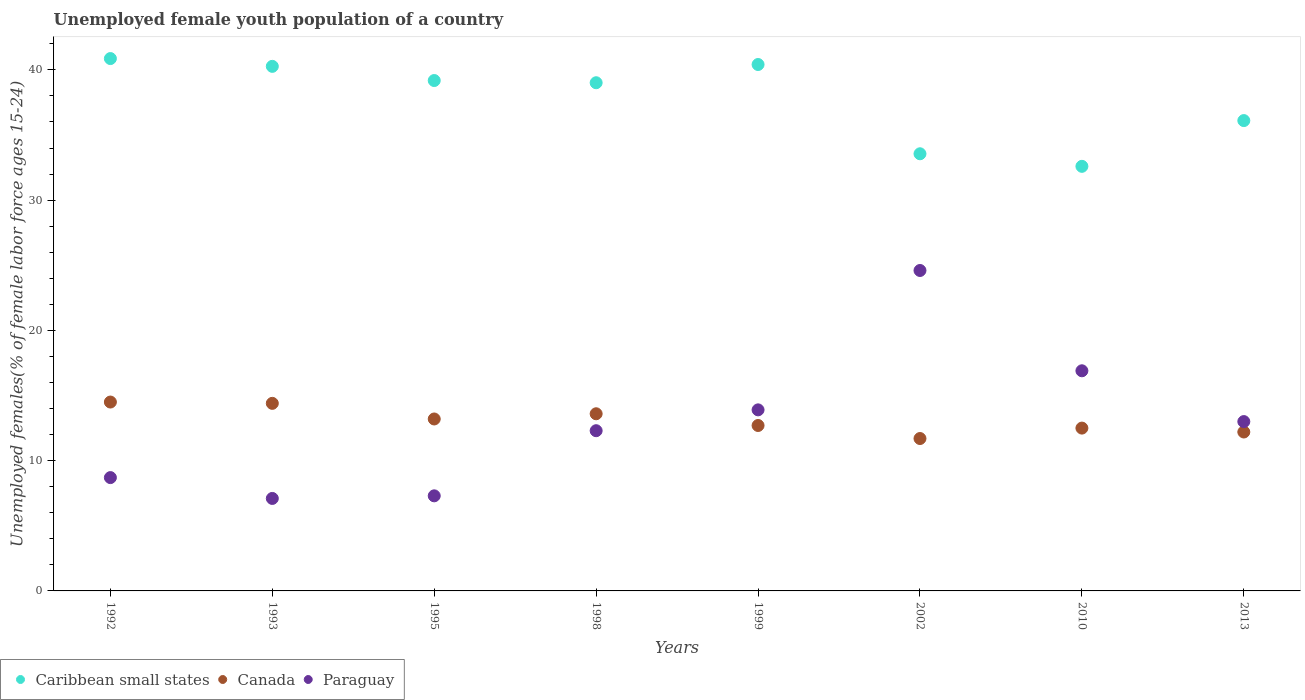How many different coloured dotlines are there?
Your answer should be compact. 3. Is the number of dotlines equal to the number of legend labels?
Make the answer very short. Yes. What is the percentage of unemployed female youth population in Caribbean small states in 2010?
Offer a very short reply. 32.6. Across all years, what is the maximum percentage of unemployed female youth population in Canada?
Provide a succinct answer. 14.5. Across all years, what is the minimum percentage of unemployed female youth population in Paraguay?
Keep it short and to the point. 7.1. In which year was the percentage of unemployed female youth population in Canada maximum?
Offer a terse response. 1992. In which year was the percentage of unemployed female youth population in Paraguay minimum?
Provide a short and direct response. 1993. What is the total percentage of unemployed female youth population in Caribbean small states in the graph?
Give a very brief answer. 302.01. What is the difference between the percentage of unemployed female youth population in Paraguay in 2010 and that in 2013?
Your response must be concise. 3.9. What is the difference between the percentage of unemployed female youth population in Canada in 1993 and the percentage of unemployed female youth population in Paraguay in 1999?
Your response must be concise. 0.5. What is the average percentage of unemployed female youth population in Caribbean small states per year?
Give a very brief answer. 37.75. In the year 1995, what is the difference between the percentage of unemployed female youth population in Canada and percentage of unemployed female youth population in Caribbean small states?
Your answer should be compact. -25.98. In how many years, is the percentage of unemployed female youth population in Caribbean small states greater than 40 %?
Provide a succinct answer. 3. What is the ratio of the percentage of unemployed female youth population in Caribbean small states in 1999 to that in 2013?
Keep it short and to the point. 1.12. Is the difference between the percentage of unemployed female youth population in Canada in 1992 and 2002 greater than the difference between the percentage of unemployed female youth population in Caribbean small states in 1992 and 2002?
Offer a very short reply. No. What is the difference between the highest and the second highest percentage of unemployed female youth population in Canada?
Provide a succinct answer. 0.1. What is the difference between the highest and the lowest percentage of unemployed female youth population in Canada?
Give a very brief answer. 2.8. In how many years, is the percentage of unemployed female youth population in Paraguay greater than the average percentage of unemployed female youth population in Paraguay taken over all years?
Your answer should be very brief. 4. Is the sum of the percentage of unemployed female youth population in Canada in 1995 and 1998 greater than the maximum percentage of unemployed female youth population in Paraguay across all years?
Keep it short and to the point. Yes. Is it the case that in every year, the sum of the percentage of unemployed female youth population in Caribbean small states and percentage of unemployed female youth population in Canada  is greater than the percentage of unemployed female youth population in Paraguay?
Your answer should be very brief. Yes. Is the percentage of unemployed female youth population in Canada strictly greater than the percentage of unemployed female youth population in Caribbean small states over the years?
Your answer should be compact. No. Is the percentage of unemployed female youth population in Caribbean small states strictly less than the percentage of unemployed female youth population in Paraguay over the years?
Ensure brevity in your answer.  No. How many dotlines are there?
Offer a very short reply. 3. How many years are there in the graph?
Keep it short and to the point. 8. Are the values on the major ticks of Y-axis written in scientific E-notation?
Ensure brevity in your answer.  No. Does the graph contain any zero values?
Offer a terse response. No. What is the title of the graph?
Give a very brief answer. Unemployed female youth population of a country. What is the label or title of the Y-axis?
Your response must be concise. Unemployed females(% of female labor force ages 15-24). What is the Unemployed females(% of female labor force ages 15-24) in Caribbean small states in 1992?
Keep it short and to the point. 40.87. What is the Unemployed females(% of female labor force ages 15-24) in Paraguay in 1992?
Make the answer very short. 8.7. What is the Unemployed females(% of female labor force ages 15-24) in Caribbean small states in 1993?
Ensure brevity in your answer.  40.27. What is the Unemployed females(% of female labor force ages 15-24) in Canada in 1993?
Ensure brevity in your answer.  14.4. What is the Unemployed females(% of female labor force ages 15-24) in Paraguay in 1993?
Keep it short and to the point. 7.1. What is the Unemployed females(% of female labor force ages 15-24) of Caribbean small states in 1995?
Your response must be concise. 39.18. What is the Unemployed females(% of female labor force ages 15-24) in Canada in 1995?
Your answer should be very brief. 13.2. What is the Unemployed females(% of female labor force ages 15-24) of Paraguay in 1995?
Give a very brief answer. 7.3. What is the Unemployed females(% of female labor force ages 15-24) in Caribbean small states in 1998?
Offer a terse response. 39.01. What is the Unemployed females(% of female labor force ages 15-24) in Canada in 1998?
Your answer should be compact. 13.6. What is the Unemployed females(% of female labor force ages 15-24) of Paraguay in 1998?
Your answer should be very brief. 12.3. What is the Unemployed females(% of female labor force ages 15-24) of Caribbean small states in 1999?
Offer a terse response. 40.41. What is the Unemployed females(% of female labor force ages 15-24) in Canada in 1999?
Ensure brevity in your answer.  12.7. What is the Unemployed females(% of female labor force ages 15-24) in Paraguay in 1999?
Offer a very short reply. 13.9. What is the Unemployed females(% of female labor force ages 15-24) of Caribbean small states in 2002?
Your answer should be compact. 33.56. What is the Unemployed females(% of female labor force ages 15-24) of Canada in 2002?
Your answer should be very brief. 11.7. What is the Unemployed females(% of female labor force ages 15-24) of Paraguay in 2002?
Your answer should be very brief. 24.6. What is the Unemployed females(% of female labor force ages 15-24) in Caribbean small states in 2010?
Offer a terse response. 32.6. What is the Unemployed females(% of female labor force ages 15-24) in Canada in 2010?
Make the answer very short. 12.5. What is the Unemployed females(% of female labor force ages 15-24) of Paraguay in 2010?
Provide a short and direct response. 16.9. What is the Unemployed females(% of female labor force ages 15-24) in Caribbean small states in 2013?
Provide a short and direct response. 36.11. What is the Unemployed females(% of female labor force ages 15-24) of Canada in 2013?
Keep it short and to the point. 12.2. Across all years, what is the maximum Unemployed females(% of female labor force ages 15-24) in Caribbean small states?
Your response must be concise. 40.87. Across all years, what is the maximum Unemployed females(% of female labor force ages 15-24) of Paraguay?
Provide a succinct answer. 24.6. Across all years, what is the minimum Unemployed females(% of female labor force ages 15-24) in Caribbean small states?
Provide a succinct answer. 32.6. Across all years, what is the minimum Unemployed females(% of female labor force ages 15-24) of Canada?
Give a very brief answer. 11.7. Across all years, what is the minimum Unemployed females(% of female labor force ages 15-24) of Paraguay?
Offer a terse response. 7.1. What is the total Unemployed females(% of female labor force ages 15-24) of Caribbean small states in the graph?
Provide a short and direct response. 302.01. What is the total Unemployed females(% of female labor force ages 15-24) in Canada in the graph?
Your answer should be very brief. 104.8. What is the total Unemployed females(% of female labor force ages 15-24) in Paraguay in the graph?
Provide a short and direct response. 103.8. What is the difference between the Unemployed females(% of female labor force ages 15-24) in Caribbean small states in 1992 and that in 1993?
Give a very brief answer. 0.6. What is the difference between the Unemployed females(% of female labor force ages 15-24) in Caribbean small states in 1992 and that in 1995?
Offer a terse response. 1.69. What is the difference between the Unemployed females(% of female labor force ages 15-24) in Paraguay in 1992 and that in 1995?
Provide a succinct answer. 1.4. What is the difference between the Unemployed females(% of female labor force ages 15-24) of Caribbean small states in 1992 and that in 1998?
Your answer should be compact. 1.86. What is the difference between the Unemployed females(% of female labor force ages 15-24) in Canada in 1992 and that in 1998?
Make the answer very short. 0.9. What is the difference between the Unemployed females(% of female labor force ages 15-24) of Paraguay in 1992 and that in 1998?
Ensure brevity in your answer.  -3.6. What is the difference between the Unemployed females(% of female labor force ages 15-24) in Caribbean small states in 1992 and that in 1999?
Keep it short and to the point. 0.46. What is the difference between the Unemployed females(% of female labor force ages 15-24) of Canada in 1992 and that in 1999?
Your response must be concise. 1.8. What is the difference between the Unemployed females(% of female labor force ages 15-24) of Caribbean small states in 1992 and that in 2002?
Ensure brevity in your answer.  7.31. What is the difference between the Unemployed females(% of female labor force ages 15-24) of Paraguay in 1992 and that in 2002?
Keep it short and to the point. -15.9. What is the difference between the Unemployed females(% of female labor force ages 15-24) in Caribbean small states in 1992 and that in 2010?
Your answer should be very brief. 8.27. What is the difference between the Unemployed females(% of female labor force ages 15-24) in Caribbean small states in 1992 and that in 2013?
Offer a terse response. 4.76. What is the difference between the Unemployed females(% of female labor force ages 15-24) in Canada in 1992 and that in 2013?
Offer a very short reply. 2.3. What is the difference between the Unemployed females(% of female labor force ages 15-24) in Caribbean small states in 1993 and that in 1995?
Offer a terse response. 1.09. What is the difference between the Unemployed females(% of female labor force ages 15-24) in Canada in 1993 and that in 1995?
Provide a succinct answer. 1.2. What is the difference between the Unemployed females(% of female labor force ages 15-24) in Paraguay in 1993 and that in 1995?
Offer a terse response. -0.2. What is the difference between the Unemployed females(% of female labor force ages 15-24) of Caribbean small states in 1993 and that in 1998?
Offer a very short reply. 1.26. What is the difference between the Unemployed females(% of female labor force ages 15-24) of Canada in 1993 and that in 1998?
Make the answer very short. 0.8. What is the difference between the Unemployed females(% of female labor force ages 15-24) in Caribbean small states in 1993 and that in 1999?
Keep it short and to the point. -0.14. What is the difference between the Unemployed females(% of female labor force ages 15-24) in Canada in 1993 and that in 1999?
Ensure brevity in your answer.  1.7. What is the difference between the Unemployed females(% of female labor force ages 15-24) in Paraguay in 1993 and that in 1999?
Ensure brevity in your answer.  -6.8. What is the difference between the Unemployed females(% of female labor force ages 15-24) of Caribbean small states in 1993 and that in 2002?
Your answer should be compact. 6.71. What is the difference between the Unemployed females(% of female labor force ages 15-24) in Canada in 1993 and that in 2002?
Provide a short and direct response. 2.7. What is the difference between the Unemployed females(% of female labor force ages 15-24) in Paraguay in 1993 and that in 2002?
Offer a terse response. -17.5. What is the difference between the Unemployed females(% of female labor force ages 15-24) in Caribbean small states in 1993 and that in 2010?
Provide a short and direct response. 7.68. What is the difference between the Unemployed females(% of female labor force ages 15-24) in Paraguay in 1993 and that in 2010?
Ensure brevity in your answer.  -9.8. What is the difference between the Unemployed females(% of female labor force ages 15-24) in Caribbean small states in 1993 and that in 2013?
Offer a very short reply. 4.16. What is the difference between the Unemployed females(% of female labor force ages 15-24) in Canada in 1993 and that in 2013?
Offer a very short reply. 2.2. What is the difference between the Unemployed females(% of female labor force ages 15-24) in Paraguay in 1993 and that in 2013?
Keep it short and to the point. -5.9. What is the difference between the Unemployed females(% of female labor force ages 15-24) in Caribbean small states in 1995 and that in 1998?
Keep it short and to the point. 0.17. What is the difference between the Unemployed females(% of female labor force ages 15-24) of Paraguay in 1995 and that in 1998?
Offer a terse response. -5. What is the difference between the Unemployed females(% of female labor force ages 15-24) of Caribbean small states in 1995 and that in 1999?
Give a very brief answer. -1.23. What is the difference between the Unemployed females(% of female labor force ages 15-24) in Paraguay in 1995 and that in 1999?
Your answer should be compact. -6.6. What is the difference between the Unemployed females(% of female labor force ages 15-24) of Caribbean small states in 1995 and that in 2002?
Give a very brief answer. 5.62. What is the difference between the Unemployed females(% of female labor force ages 15-24) in Canada in 1995 and that in 2002?
Offer a terse response. 1.5. What is the difference between the Unemployed females(% of female labor force ages 15-24) of Paraguay in 1995 and that in 2002?
Offer a very short reply. -17.3. What is the difference between the Unemployed females(% of female labor force ages 15-24) in Caribbean small states in 1995 and that in 2010?
Provide a short and direct response. 6.59. What is the difference between the Unemployed females(% of female labor force ages 15-24) of Paraguay in 1995 and that in 2010?
Offer a terse response. -9.6. What is the difference between the Unemployed females(% of female labor force ages 15-24) of Caribbean small states in 1995 and that in 2013?
Make the answer very short. 3.08. What is the difference between the Unemployed females(% of female labor force ages 15-24) of Paraguay in 1995 and that in 2013?
Ensure brevity in your answer.  -5.7. What is the difference between the Unemployed females(% of female labor force ages 15-24) in Caribbean small states in 1998 and that in 1999?
Provide a succinct answer. -1.4. What is the difference between the Unemployed females(% of female labor force ages 15-24) of Canada in 1998 and that in 1999?
Provide a succinct answer. 0.9. What is the difference between the Unemployed females(% of female labor force ages 15-24) of Paraguay in 1998 and that in 1999?
Make the answer very short. -1.6. What is the difference between the Unemployed females(% of female labor force ages 15-24) in Caribbean small states in 1998 and that in 2002?
Keep it short and to the point. 5.45. What is the difference between the Unemployed females(% of female labor force ages 15-24) of Canada in 1998 and that in 2002?
Your answer should be compact. 1.9. What is the difference between the Unemployed females(% of female labor force ages 15-24) of Caribbean small states in 1998 and that in 2010?
Keep it short and to the point. 6.42. What is the difference between the Unemployed females(% of female labor force ages 15-24) in Caribbean small states in 1998 and that in 2013?
Provide a succinct answer. 2.91. What is the difference between the Unemployed females(% of female labor force ages 15-24) in Paraguay in 1998 and that in 2013?
Give a very brief answer. -0.7. What is the difference between the Unemployed females(% of female labor force ages 15-24) in Caribbean small states in 1999 and that in 2002?
Provide a short and direct response. 6.85. What is the difference between the Unemployed females(% of female labor force ages 15-24) in Canada in 1999 and that in 2002?
Offer a very short reply. 1. What is the difference between the Unemployed females(% of female labor force ages 15-24) of Caribbean small states in 1999 and that in 2010?
Give a very brief answer. 7.82. What is the difference between the Unemployed females(% of female labor force ages 15-24) in Caribbean small states in 1999 and that in 2013?
Your response must be concise. 4.31. What is the difference between the Unemployed females(% of female labor force ages 15-24) in Canada in 1999 and that in 2013?
Keep it short and to the point. 0.5. What is the difference between the Unemployed females(% of female labor force ages 15-24) in Paraguay in 1999 and that in 2013?
Your answer should be very brief. 0.9. What is the difference between the Unemployed females(% of female labor force ages 15-24) in Caribbean small states in 2002 and that in 2010?
Your answer should be very brief. 0.96. What is the difference between the Unemployed females(% of female labor force ages 15-24) in Paraguay in 2002 and that in 2010?
Make the answer very short. 7.7. What is the difference between the Unemployed females(% of female labor force ages 15-24) of Caribbean small states in 2002 and that in 2013?
Your answer should be compact. -2.55. What is the difference between the Unemployed females(% of female labor force ages 15-24) in Paraguay in 2002 and that in 2013?
Give a very brief answer. 11.6. What is the difference between the Unemployed females(% of female labor force ages 15-24) in Caribbean small states in 2010 and that in 2013?
Ensure brevity in your answer.  -3.51. What is the difference between the Unemployed females(% of female labor force ages 15-24) in Paraguay in 2010 and that in 2013?
Offer a very short reply. 3.9. What is the difference between the Unemployed females(% of female labor force ages 15-24) of Caribbean small states in 1992 and the Unemployed females(% of female labor force ages 15-24) of Canada in 1993?
Provide a succinct answer. 26.47. What is the difference between the Unemployed females(% of female labor force ages 15-24) in Caribbean small states in 1992 and the Unemployed females(% of female labor force ages 15-24) in Paraguay in 1993?
Your response must be concise. 33.77. What is the difference between the Unemployed females(% of female labor force ages 15-24) of Canada in 1992 and the Unemployed females(% of female labor force ages 15-24) of Paraguay in 1993?
Ensure brevity in your answer.  7.4. What is the difference between the Unemployed females(% of female labor force ages 15-24) in Caribbean small states in 1992 and the Unemployed females(% of female labor force ages 15-24) in Canada in 1995?
Your answer should be compact. 27.67. What is the difference between the Unemployed females(% of female labor force ages 15-24) of Caribbean small states in 1992 and the Unemployed females(% of female labor force ages 15-24) of Paraguay in 1995?
Your answer should be very brief. 33.57. What is the difference between the Unemployed females(% of female labor force ages 15-24) of Canada in 1992 and the Unemployed females(% of female labor force ages 15-24) of Paraguay in 1995?
Make the answer very short. 7.2. What is the difference between the Unemployed females(% of female labor force ages 15-24) of Caribbean small states in 1992 and the Unemployed females(% of female labor force ages 15-24) of Canada in 1998?
Your answer should be compact. 27.27. What is the difference between the Unemployed females(% of female labor force ages 15-24) of Caribbean small states in 1992 and the Unemployed females(% of female labor force ages 15-24) of Paraguay in 1998?
Keep it short and to the point. 28.57. What is the difference between the Unemployed females(% of female labor force ages 15-24) in Caribbean small states in 1992 and the Unemployed females(% of female labor force ages 15-24) in Canada in 1999?
Make the answer very short. 28.17. What is the difference between the Unemployed females(% of female labor force ages 15-24) of Caribbean small states in 1992 and the Unemployed females(% of female labor force ages 15-24) of Paraguay in 1999?
Give a very brief answer. 26.97. What is the difference between the Unemployed females(% of female labor force ages 15-24) of Canada in 1992 and the Unemployed females(% of female labor force ages 15-24) of Paraguay in 1999?
Your answer should be compact. 0.6. What is the difference between the Unemployed females(% of female labor force ages 15-24) of Caribbean small states in 1992 and the Unemployed females(% of female labor force ages 15-24) of Canada in 2002?
Offer a very short reply. 29.17. What is the difference between the Unemployed females(% of female labor force ages 15-24) of Caribbean small states in 1992 and the Unemployed females(% of female labor force ages 15-24) of Paraguay in 2002?
Make the answer very short. 16.27. What is the difference between the Unemployed females(% of female labor force ages 15-24) of Canada in 1992 and the Unemployed females(% of female labor force ages 15-24) of Paraguay in 2002?
Keep it short and to the point. -10.1. What is the difference between the Unemployed females(% of female labor force ages 15-24) of Caribbean small states in 1992 and the Unemployed females(% of female labor force ages 15-24) of Canada in 2010?
Your response must be concise. 28.37. What is the difference between the Unemployed females(% of female labor force ages 15-24) in Caribbean small states in 1992 and the Unemployed females(% of female labor force ages 15-24) in Paraguay in 2010?
Keep it short and to the point. 23.97. What is the difference between the Unemployed females(% of female labor force ages 15-24) of Canada in 1992 and the Unemployed females(% of female labor force ages 15-24) of Paraguay in 2010?
Your answer should be compact. -2.4. What is the difference between the Unemployed females(% of female labor force ages 15-24) of Caribbean small states in 1992 and the Unemployed females(% of female labor force ages 15-24) of Canada in 2013?
Provide a succinct answer. 28.67. What is the difference between the Unemployed females(% of female labor force ages 15-24) of Caribbean small states in 1992 and the Unemployed females(% of female labor force ages 15-24) of Paraguay in 2013?
Your response must be concise. 27.87. What is the difference between the Unemployed females(% of female labor force ages 15-24) of Canada in 1992 and the Unemployed females(% of female labor force ages 15-24) of Paraguay in 2013?
Offer a terse response. 1.5. What is the difference between the Unemployed females(% of female labor force ages 15-24) of Caribbean small states in 1993 and the Unemployed females(% of female labor force ages 15-24) of Canada in 1995?
Keep it short and to the point. 27.07. What is the difference between the Unemployed females(% of female labor force ages 15-24) in Caribbean small states in 1993 and the Unemployed females(% of female labor force ages 15-24) in Paraguay in 1995?
Provide a short and direct response. 32.97. What is the difference between the Unemployed females(% of female labor force ages 15-24) in Canada in 1993 and the Unemployed females(% of female labor force ages 15-24) in Paraguay in 1995?
Keep it short and to the point. 7.1. What is the difference between the Unemployed females(% of female labor force ages 15-24) of Caribbean small states in 1993 and the Unemployed females(% of female labor force ages 15-24) of Canada in 1998?
Your answer should be compact. 26.67. What is the difference between the Unemployed females(% of female labor force ages 15-24) in Caribbean small states in 1993 and the Unemployed females(% of female labor force ages 15-24) in Paraguay in 1998?
Offer a very short reply. 27.97. What is the difference between the Unemployed females(% of female labor force ages 15-24) of Canada in 1993 and the Unemployed females(% of female labor force ages 15-24) of Paraguay in 1998?
Make the answer very short. 2.1. What is the difference between the Unemployed females(% of female labor force ages 15-24) of Caribbean small states in 1993 and the Unemployed females(% of female labor force ages 15-24) of Canada in 1999?
Your answer should be compact. 27.57. What is the difference between the Unemployed females(% of female labor force ages 15-24) in Caribbean small states in 1993 and the Unemployed females(% of female labor force ages 15-24) in Paraguay in 1999?
Provide a short and direct response. 26.37. What is the difference between the Unemployed females(% of female labor force ages 15-24) of Canada in 1993 and the Unemployed females(% of female labor force ages 15-24) of Paraguay in 1999?
Your answer should be very brief. 0.5. What is the difference between the Unemployed females(% of female labor force ages 15-24) of Caribbean small states in 1993 and the Unemployed females(% of female labor force ages 15-24) of Canada in 2002?
Offer a very short reply. 28.57. What is the difference between the Unemployed females(% of female labor force ages 15-24) of Caribbean small states in 1993 and the Unemployed females(% of female labor force ages 15-24) of Paraguay in 2002?
Provide a succinct answer. 15.67. What is the difference between the Unemployed females(% of female labor force ages 15-24) of Canada in 1993 and the Unemployed females(% of female labor force ages 15-24) of Paraguay in 2002?
Your answer should be very brief. -10.2. What is the difference between the Unemployed females(% of female labor force ages 15-24) in Caribbean small states in 1993 and the Unemployed females(% of female labor force ages 15-24) in Canada in 2010?
Provide a short and direct response. 27.77. What is the difference between the Unemployed females(% of female labor force ages 15-24) in Caribbean small states in 1993 and the Unemployed females(% of female labor force ages 15-24) in Paraguay in 2010?
Give a very brief answer. 23.37. What is the difference between the Unemployed females(% of female labor force ages 15-24) in Caribbean small states in 1993 and the Unemployed females(% of female labor force ages 15-24) in Canada in 2013?
Offer a very short reply. 28.07. What is the difference between the Unemployed females(% of female labor force ages 15-24) of Caribbean small states in 1993 and the Unemployed females(% of female labor force ages 15-24) of Paraguay in 2013?
Your answer should be compact. 27.27. What is the difference between the Unemployed females(% of female labor force ages 15-24) in Caribbean small states in 1995 and the Unemployed females(% of female labor force ages 15-24) in Canada in 1998?
Your answer should be very brief. 25.58. What is the difference between the Unemployed females(% of female labor force ages 15-24) in Caribbean small states in 1995 and the Unemployed females(% of female labor force ages 15-24) in Paraguay in 1998?
Your answer should be very brief. 26.88. What is the difference between the Unemployed females(% of female labor force ages 15-24) of Canada in 1995 and the Unemployed females(% of female labor force ages 15-24) of Paraguay in 1998?
Keep it short and to the point. 0.9. What is the difference between the Unemployed females(% of female labor force ages 15-24) of Caribbean small states in 1995 and the Unemployed females(% of female labor force ages 15-24) of Canada in 1999?
Provide a succinct answer. 26.48. What is the difference between the Unemployed females(% of female labor force ages 15-24) in Caribbean small states in 1995 and the Unemployed females(% of female labor force ages 15-24) in Paraguay in 1999?
Give a very brief answer. 25.28. What is the difference between the Unemployed females(% of female labor force ages 15-24) of Caribbean small states in 1995 and the Unemployed females(% of female labor force ages 15-24) of Canada in 2002?
Offer a very short reply. 27.48. What is the difference between the Unemployed females(% of female labor force ages 15-24) of Caribbean small states in 1995 and the Unemployed females(% of female labor force ages 15-24) of Paraguay in 2002?
Make the answer very short. 14.58. What is the difference between the Unemployed females(% of female labor force ages 15-24) of Canada in 1995 and the Unemployed females(% of female labor force ages 15-24) of Paraguay in 2002?
Your response must be concise. -11.4. What is the difference between the Unemployed females(% of female labor force ages 15-24) in Caribbean small states in 1995 and the Unemployed females(% of female labor force ages 15-24) in Canada in 2010?
Provide a succinct answer. 26.68. What is the difference between the Unemployed females(% of female labor force ages 15-24) of Caribbean small states in 1995 and the Unemployed females(% of female labor force ages 15-24) of Paraguay in 2010?
Provide a succinct answer. 22.28. What is the difference between the Unemployed females(% of female labor force ages 15-24) in Canada in 1995 and the Unemployed females(% of female labor force ages 15-24) in Paraguay in 2010?
Ensure brevity in your answer.  -3.7. What is the difference between the Unemployed females(% of female labor force ages 15-24) of Caribbean small states in 1995 and the Unemployed females(% of female labor force ages 15-24) of Canada in 2013?
Offer a terse response. 26.98. What is the difference between the Unemployed females(% of female labor force ages 15-24) of Caribbean small states in 1995 and the Unemployed females(% of female labor force ages 15-24) of Paraguay in 2013?
Offer a very short reply. 26.18. What is the difference between the Unemployed females(% of female labor force ages 15-24) of Canada in 1995 and the Unemployed females(% of female labor force ages 15-24) of Paraguay in 2013?
Provide a short and direct response. 0.2. What is the difference between the Unemployed females(% of female labor force ages 15-24) in Caribbean small states in 1998 and the Unemployed females(% of female labor force ages 15-24) in Canada in 1999?
Ensure brevity in your answer.  26.31. What is the difference between the Unemployed females(% of female labor force ages 15-24) of Caribbean small states in 1998 and the Unemployed females(% of female labor force ages 15-24) of Paraguay in 1999?
Keep it short and to the point. 25.11. What is the difference between the Unemployed females(% of female labor force ages 15-24) in Canada in 1998 and the Unemployed females(% of female labor force ages 15-24) in Paraguay in 1999?
Offer a terse response. -0.3. What is the difference between the Unemployed females(% of female labor force ages 15-24) of Caribbean small states in 1998 and the Unemployed females(% of female labor force ages 15-24) of Canada in 2002?
Ensure brevity in your answer.  27.31. What is the difference between the Unemployed females(% of female labor force ages 15-24) in Caribbean small states in 1998 and the Unemployed females(% of female labor force ages 15-24) in Paraguay in 2002?
Your response must be concise. 14.41. What is the difference between the Unemployed females(% of female labor force ages 15-24) of Caribbean small states in 1998 and the Unemployed females(% of female labor force ages 15-24) of Canada in 2010?
Ensure brevity in your answer.  26.51. What is the difference between the Unemployed females(% of female labor force ages 15-24) in Caribbean small states in 1998 and the Unemployed females(% of female labor force ages 15-24) in Paraguay in 2010?
Provide a succinct answer. 22.11. What is the difference between the Unemployed females(% of female labor force ages 15-24) in Caribbean small states in 1998 and the Unemployed females(% of female labor force ages 15-24) in Canada in 2013?
Provide a succinct answer. 26.81. What is the difference between the Unemployed females(% of female labor force ages 15-24) in Caribbean small states in 1998 and the Unemployed females(% of female labor force ages 15-24) in Paraguay in 2013?
Ensure brevity in your answer.  26.01. What is the difference between the Unemployed females(% of female labor force ages 15-24) of Canada in 1998 and the Unemployed females(% of female labor force ages 15-24) of Paraguay in 2013?
Give a very brief answer. 0.6. What is the difference between the Unemployed females(% of female labor force ages 15-24) of Caribbean small states in 1999 and the Unemployed females(% of female labor force ages 15-24) of Canada in 2002?
Your response must be concise. 28.71. What is the difference between the Unemployed females(% of female labor force ages 15-24) in Caribbean small states in 1999 and the Unemployed females(% of female labor force ages 15-24) in Paraguay in 2002?
Offer a very short reply. 15.81. What is the difference between the Unemployed females(% of female labor force ages 15-24) in Caribbean small states in 1999 and the Unemployed females(% of female labor force ages 15-24) in Canada in 2010?
Keep it short and to the point. 27.91. What is the difference between the Unemployed females(% of female labor force ages 15-24) of Caribbean small states in 1999 and the Unemployed females(% of female labor force ages 15-24) of Paraguay in 2010?
Your answer should be compact. 23.51. What is the difference between the Unemployed females(% of female labor force ages 15-24) in Canada in 1999 and the Unemployed females(% of female labor force ages 15-24) in Paraguay in 2010?
Keep it short and to the point. -4.2. What is the difference between the Unemployed females(% of female labor force ages 15-24) of Caribbean small states in 1999 and the Unemployed females(% of female labor force ages 15-24) of Canada in 2013?
Offer a very short reply. 28.21. What is the difference between the Unemployed females(% of female labor force ages 15-24) of Caribbean small states in 1999 and the Unemployed females(% of female labor force ages 15-24) of Paraguay in 2013?
Offer a terse response. 27.41. What is the difference between the Unemployed females(% of female labor force ages 15-24) in Caribbean small states in 2002 and the Unemployed females(% of female labor force ages 15-24) in Canada in 2010?
Your response must be concise. 21.06. What is the difference between the Unemployed females(% of female labor force ages 15-24) of Caribbean small states in 2002 and the Unemployed females(% of female labor force ages 15-24) of Paraguay in 2010?
Make the answer very short. 16.66. What is the difference between the Unemployed females(% of female labor force ages 15-24) in Caribbean small states in 2002 and the Unemployed females(% of female labor force ages 15-24) in Canada in 2013?
Your answer should be compact. 21.36. What is the difference between the Unemployed females(% of female labor force ages 15-24) of Caribbean small states in 2002 and the Unemployed females(% of female labor force ages 15-24) of Paraguay in 2013?
Ensure brevity in your answer.  20.56. What is the difference between the Unemployed females(% of female labor force ages 15-24) of Canada in 2002 and the Unemployed females(% of female labor force ages 15-24) of Paraguay in 2013?
Offer a very short reply. -1.3. What is the difference between the Unemployed females(% of female labor force ages 15-24) in Caribbean small states in 2010 and the Unemployed females(% of female labor force ages 15-24) in Canada in 2013?
Provide a short and direct response. 20.4. What is the difference between the Unemployed females(% of female labor force ages 15-24) of Caribbean small states in 2010 and the Unemployed females(% of female labor force ages 15-24) of Paraguay in 2013?
Make the answer very short. 19.6. What is the average Unemployed females(% of female labor force ages 15-24) of Caribbean small states per year?
Offer a very short reply. 37.75. What is the average Unemployed females(% of female labor force ages 15-24) of Paraguay per year?
Your response must be concise. 12.97. In the year 1992, what is the difference between the Unemployed females(% of female labor force ages 15-24) in Caribbean small states and Unemployed females(% of female labor force ages 15-24) in Canada?
Make the answer very short. 26.37. In the year 1992, what is the difference between the Unemployed females(% of female labor force ages 15-24) of Caribbean small states and Unemployed females(% of female labor force ages 15-24) of Paraguay?
Ensure brevity in your answer.  32.17. In the year 1993, what is the difference between the Unemployed females(% of female labor force ages 15-24) in Caribbean small states and Unemployed females(% of female labor force ages 15-24) in Canada?
Keep it short and to the point. 25.87. In the year 1993, what is the difference between the Unemployed females(% of female labor force ages 15-24) of Caribbean small states and Unemployed females(% of female labor force ages 15-24) of Paraguay?
Provide a succinct answer. 33.17. In the year 1993, what is the difference between the Unemployed females(% of female labor force ages 15-24) in Canada and Unemployed females(% of female labor force ages 15-24) in Paraguay?
Give a very brief answer. 7.3. In the year 1995, what is the difference between the Unemployed females(% of female labor force ages 15-24) of Caribbean small states and Unemployed females(% of female labor force ages 15-24) of Canada?
Give a very brief answer. 25.98. In the year 1995, what is the difference between the Unemployed females(% of female labor force ages 15-24) of Caribbean small states and Unemployed females(% of female labor force ages 15-24) of Paraguay?
Keep it short and to the point. 31.88. In the year 1995, what is the difference between the Unemployed females(% of female labor force ages 15-24) of Canada and Unemployed females(% of female labor force ages 15-24) of Paraguay?
Your response must be concise. 5.9. In the year 1998, what is the difference between the Unemployed females(% of female labor force ages 15-24) of Caribbean small states and Unemployed females(% of female labor force ages 15-24) of Canada?
Offer a terse response. 25.41. In the year 1998, what is the difference between the Unemployed females(% of female labor force ages 15-24) of Caribbean small states and Unemployed females(% of female labor force ages 15-24) of Paraguay?
Make the answer very short. 26.71. In the year 1999, what is the difference between the Unemployed females(% of female labor force ages 15-24) of Caribbean small states and Unemployed females(% of female labor force ages 15-24) of Canada?
Your answer should be very brief. 27.71. In the year 1999, what is the difference between the Unemployed females(% of female labor force ages 15-24) of Caribbean small states and Unemployed females(% of female labor force ages 15-24) of Paraguay?
Ensure brevity in your answer.  26.51. In the year 1999, what is the difference between the Unemployed females(% of female labor force ages 15-24) in Canada and Unemployed females(% of female labor force ages 15-24) in Paraguay?
Your answer should be very brief. -1.2. In the year 2002, what is the difference between the Unemployed females(% of female labor force ages 15-24) in Caribbean small states and Unemployed females(% of female labor force ages 15-24) in Canada?
Ensure brevity in your answer.  21.86. In the year 2002, what is the difference between the Unemployed females(% of female labor force ages 15-24) in Caribbean small states and Unemployed females(% of female labor force ages 15-24) in Paraguay?
Provide a succinct answer. 8.96. In the year 2010, what is the difference between the Unemployed females(% of female labor force ages 15-24) in Caribbean small states and Unemployed females(% of female labor force ages 15-24) in Canada?
Your answer should be compact. 20.1. In the year 2010, what is the difference between the Unemployed females(% of female labor force ages 15-24) in Caribbean small states and Unemployed females(% of female labor force ages 15-24) in Paraguay?
Your answer should be very brief. 15.7. In the year 2010, what is the difference between the Unemployed females(% of female labor force ages 15-24) of Canada and Unemployed females(% of female labor force ages 15-24) of Paraguay?
Ensure brevity in your answer.  -4.4. In the year 2013, what is the difference between the Unemployed females(% of female labor force ages 15-24) of Caribbean small states and Unemployed females(% of female labor force ages 15-24) of Canada?
Provide a short and direct response. 23.91. In the year 2013, what is the difference between the Unemployed females(% of female labor force ages 15-24) in Caribbean small states and Unemployed females(% of female labor force ages 15-24) in Paraguay?
Your answer should be compact. 23.11. In the year 2013, what is the difference between the Unemployed females(% of female labor force ages 15-24) in Canada and Unemployed females(% of female labor force ages 15-24) in Paraguay?
Your answer should be very brief. -0.8. What is the ratio of the Unemployed females(% of female labor force ages 15-24) in Caribbean small states in 1992 to that in 1993?
Keep it short and to the point. 1.01. What is the ratio of the Unemployed females(% of female labor force ages 15-24) in Canada in 1992 to that in 1993?
Your response must be concise. 1.01. What is the ratio of the Unemployed females(% of female labor force ages 15-24) of Paraguay in 1992 to that in 1993?
Make the answer very short. 1.23. What is the ratio of the Unemployed females(% of female labor force ages 15-24) of Caribbean small states in 1992 to that in 1995?
Your answer should be very brief. 1.04. What is the ratio of the Unemployed females(% of female labor force ages 15-24) in Canada in 1992 to that in 1995?
Give a very brief answer. 1.1. What is the ratio of the Unemployed females(% of female labor force ages 15-24) in Paraguay in 1992 to that in 1995?
Provide a short and direct response. 1.19. What is the ratio of the Unemployed females(% of female labor force ages 15-24) of Caribbean small states in 1992 to that in 1998?
Offer a terse response. 1.05. What is the ratio of the Unemployed females(% of female labor force ages 15-24) in Canada in 1992 to that in 1998?
Provide a short and direct response. 1.07. What is the ratio of the Unemployed females(% of female labor force ages 15-24) of Paraguay in 1992 to that in 1998?
Offer a terse response. 0.71. What is the ratio of the Unemployed females(% of female labor force ages 15-24) of Caribbean small states in 1992 to that in 1999?
Your answer should be very brief. 1.01. What is the ratio of the Unemployed females(% of female labor force ages 15-24) in Canada in 1992 to that in 1999?
Provide a short and direct response. 1.14. What is the ratio of the Unemployed females(% of female labor force ages 15-24) in Paraguay in 1992 to that in 1999?
Your answer should be compact. 0.63. What is the ratio of the Unemployed females(% of female labor force ages 15-24) of Caribbean small states in 1992 to that in 2002?
Provide a short and direct response. 1.22. What is the ratio of the Unemployed females(% of female labor force ages 15-24) in Canada in 1992 to that in 2002?
Offer a terse response. 1.24. What is the ratio of the Unemployed females(% of female labor force ages 15-24) in Paraguay in 1992 to that in 2002?
Keep it short and to the point. 0.35. What is the ratio of the Unemployed females(% of female labor force ages 15-24) in Caribbean small states in 1992 to that in 2010?
Make the answer very short. 1.25. What is the ratio of the Unemployed females(% of female labor force ages 15-24) of Canada in 1992 to that in 2010?
Provide a succinct answer. 1.16. What is the ratio of the Unemployed females(% of female labor force ages 15-24) in Paraguay in 1992 to that in 2010?
Provide a succinct answer. 0.51. What is the ratio of the Unemployed females(% of female labor force ages 15-24) in Caribbean small states in 1992 to that in 2013?
Provide a succinct answer. 1.13. What is the ratio of the Unemployed females(% of female labor force ages 15-24) of Canada in 1992 to that in 2013?
Provide a short and direct response. 1.19. What is the ratio of the Unemployed females(% of female labor force ages 15-24) of Paraguay in 1992 to that in 2013?
Provide a short and direct response. 0.67. What is the ratio of the Unemployed females(% of female labor force ages 15-24) of Caribbean small states in 1993 to that in 1995?
Provide a succinct answer. 1.03. What is the ratio of the Unemployed females(% of female labor force ages 15-24) of Canada in 1993 to that in 1995?
Your response must be concise. 1.09. What is the ratio of the Unemployed females(% of female labor force ages 15-24) of Paraguay in 1993 to that in 1995?
Your response must be concise. 0.97. What is the ratio of the Unemployed females(% of female labor force ages 15-24) of Caribbean small states in 1993 to that in 1998?
Make the answer very short. 1.03. What is the ratio of the Unemployed females(% of female labor force ages 15-24) in Canada in 1993 to that in 1998?
Your response must be concise. 1.06. What is the ratio of the Unemployed females(% of female labor force ages 15-24) of Paraguay in 1993 to that in 1998?
Your answer should be very brief. 0.58. What is the ratio of the Unemployed females(% of female labor force ages 15-24) of Caribbean small states in 1993 to that in 1999?
Offer a terse response. 1. What is the ratio of the Unemployed females(% of female labor force ages 15-24) of Canada in 1993 to that in 1999?
Your answer should be compact. 1.13. What is the ratio of the Unemployed females(% of female labor force ages 15-24) of Paraguay in 1993 to that in 1999?
Keep it short and to the point. 0.51. What is the ratio of the Unemployed females(% of female labor force ages 15-24) of Caribbean small states in 1993 to that in 2002?
Keep it short and to the point. 1.2. What is the ratio of the Unemployed females(% of female labor force ages 15-24) in Canada in 1993 to that in 2002?
Make the answer very short. 1.23. What is the ratio of the Unemployed females(% of female labor force ages 15-24) of Paraguay in 1993 to that in 2002?
Provide a short and direct response. 0.29. What is the ratio of the Unemployed females(% of female labor force ages 15-24) in Caribbean small states in 1993 to that in 2010?
Keep it short and to the point. 1.24. What is the ratio of the Unemployed females(% of female labor force ages 15-24) in Canada in 1993 to that in 2010?
Keep it short and to the point. 1.15. What is the ratio of the Unemployed females(% of female labor force ages 15-24) in Paraguay in 1993 to that in 2010?
Ensure brevity in your answer.  0.42. What is the ratio of the Unemployed females(% of female labor force ages 15-24) of Caribbean small states in 1993 to that in 2013?
Offer a terse response. 1.12. What is the ratio of the Unemployed females(% of female labor force ages 15-24) in Canada in 1993 to that in 2013?
Your answer should be compact. 1.18. What is the ratio of the Unemployed females(% of female labor force ages 15-24) in Paraguay in 1993 to that in 2013?
Offer a terse response. 0.55. What is the ratio of the Unemployed females(% of female labor force ages 15-24) in Caribbean small states in 1995 to that in 1998?
Provide a short and direct response. 1. What is the ratio of the Unemployed females(% of female labor force ages 15-24) in Canada in 1995 to that in 1998?
Offer a very short reply. 0.97. What is the ratio of the Unemployed females(% of female labor force ages 15-24) of Paraguay in 1995 to that in 1998?
Offer a terse response. 0.59. What is the ratio of the Unemployed females(% of female labor force ages 15-24) in Caribbean small states in 1995 to that in 1999?
Offer a terse response. 0.97. What is the ratio of the Unemployed females(% of female labor force ages 15-24) in Canada in 1995 to that in 1999?
Your response must be concise. 1.04. What is the ratio of the Unemployed females(% of female labor force ages 15-24) of Paraguay in 1995 to that in 1999?
Keep it short and to the point. 0.53. What is the ratio of the Unemployed females(% of female labor force ages 15-24) in Caribbean small states in 1995 to that in 2002?
Your answer should be very brief. 1.17. What is the ratio of the Unemployed females(% of female labor force ages 15-24) in Canada in 1995 to that in 2002?
Offer a very short reply. 1.13. What is the ratio of the Unemployed females(% of female labor force ages 15-24) of Paraguay in 1995 to that in 2002?
Provide a succinct answer. 0.3. What is the ratio of the Unemployed females(% of female labor force ages 15-24) in Caribbean small states in 1995 to that in 2010?
Ensure brevity in your answer.  1.2. What is the ratio of the Unemployed females(% of female labor force ages 15-24) of Canada in 1995 to that in 2010?
Offer a terse response. 1.06. What is the ratio of the Unemployed females(% of female labor force ages 15-24) in Paraguay in 1995 to that in 2010?
Your answer should be very brief. 0.43. What is the ratio of the Unemployed females(% of female labor force ages 15-24) in Caribbean small states in 1995 to that in 2013?
Keep it short and to the point. 1.09. What is the ratio of the Unemployed females(% of female labor force ages 15-24) in Canada in 1995 to that in 2013?
Provide a short and direct response. 1.08. What is the ratio of the Unemployed females(% of female labor force ages 15-24) in Paraguay in 1995 to that in 2013?
Provide a short and direct response. 0.56. What is the ratio of the Unemployed females(% of female labor force ages 15-24) of Caribbean small states in 1998 to that in 1999?
Your response must be concise. 0.97. What is the ratio of the Unemployed females(% of female labor force ages 15-24) of Canada in 1998 to that in 1999?
Provide a succinct answer. 1.07. What is the ratio of the Unemployed females(% of female labor force ages 15-24) of Paraguay in 1998 to that in 1999?
Keep it short and to the point. 0.88. What is the ratio of the Unemployed females(% of female labor force ages 15-24) of Caribbean small states in 1998 to that in 2002?
Make the answer very short. 1.16. What is the ratio of the Unemployed females(% of female labor force ages 15-24) in Canada in 1998 to that in 2002?
Keep it short and to the point. 1.16. What is the ratio of the Unemployed females(% of female labor force ages 15-24) in Paraguay in 1998 to that in 2002?
Your answer should be compact. 0.5. What is the ratio of the Unemployed females(% of female labor force ages 15-24) of Caribbean small states in 1998 to that in 2010?
Provide a short and direct response. 1.2. What is the ratio of the Unemployed females(% of female labor force ages 15-24) in Canada in 1998 to that in 2010?
Provide a short and direct response. 1.09. What is the ratio of the Unemployed females(% of female labor force ages 15-24) of Paraguay in 1998 to that in 2010?
Give a very brief answer. 0.73. What is the ratio of the Unemployed females(% of female labor force ages 15-24) of Caribbean small states in 1998 to that in 2013?
Offer a terse response. 1.08. What is the ratio of the Unemployed females(% of female labor force ages 15-24) in Canada in 1998 to that in 2013?
Provide a short and direct response. 1.11. What is the ratio of the Unemployed females(% of female labor force ages 15-24) of Paraguay in 1998 to that in 2013?
Keep it short and to the point. 0.95. What is the ratio of the Unemployed females(% of female labor force ages 15-24) in Caribbean small states in 1999 to that in 2002?
Offer a very short reply. 1.2. What is the ratio of the Unemployed females(% of female labor force ages 15-24) of Canada in 1999 to that in 2002?
Offer a very short reply. 1.09. What is the ratio of the Unemployed females(% of female labor force ages 15-24) in Paraguay in 1999 to that in 2002?
Offer a terse response. 0.56. What is the ratio of the Unemployed females(% of female labor force ages 15-24) in Caribbean small states in 1999 to that in 2010?
Give a very brief answer. 1.24. What is the ratio of the Unemployed females(% of female labor force ages 15-24) of Paraguay in 1999 to that in 2010?
Your response must be concise. 0.82. What is the ratio of the Unemployed females(% of female labor force ages 15-24) in Caribbean small states in 1999 to that in 2013?
Offer a terse response. 1.12. What is the ratio of the Unemployed females(% of female labor force ages 15-24) in Canada in 1999 to that in 2013?
Your response must be concise. 1.04. What is the ratio of the Unemployed females(% of female labor force ages 15-24) in Paraguay in 1999 to that in 2013?
Provide a short and direct response. 1.07. What is the ratio of the Unemployed females(% of female labor force ages 15-24) in Caribbean small states in 2002 to that in 2010?
Offer a terse response. 1.03. What is the ratio of the Unemployed females(% of female labor force ages 15-24) of Canada in 2002 to that in 2010?
Give a very brief answer. 0.94. What is the ratio of the Unemployed females(% of female labor force ages 15-24) in Paraguay in 2002 to that in 2010?
Provide a succinct answer. 1.46. What is the ratio of the Unemployed females(% of female labor force ages 15-24) in Caribbean small states in 2002 to that in 2013?
Make the answer very short. 0.93. What is the ratio of the Unemployed females(% of female labor force ages 15-24) in Canada in 2002 to that in 2013?
Provide a succinct answer. 0.96. What is the ratio of the Unemployed females(% of female labor force ages 15-24) of Paraguay in 2002 to that in 2013?
Keep it short and to the point. 1.89. What is the ratio of the Unemployed females(% of female labor force ages 15-24) of Caribbean small states in 2010 to that in 2013?
Make the answer very short. 0.9. What is the ratio of the Unemployed females(% of female labor force ages 15-24) in Canada in 2010 to that in 2013?
Give a very brief answer. 1.02. What is the ratio of the Unemployed females(% of female labor force ages 15-24) in Paraguay in 2010 to that in 2013?
Provide a succinct answer. 1.3. What is the difference between the highest and the second highest Unemployed females(% of female labor force ages 15-24) of Caribbean small states?
Your response must be concise. 0.46. What is the difference between the highest and the lowest Unemployed females(% of female labor force ages 15-24) in Caribbean small states?
Your answer should be very brief. 8.27. What is the difference between the highest and the lowest Unemployed females(% of female labor force ages 15-24) of Canada?
Give a very brief answer. 2.8. What is the difference between the highest and the lowest Unemployed females(% of female labor force ages 15-24) of Paraguay?
Your response must be concise. 17.5. 